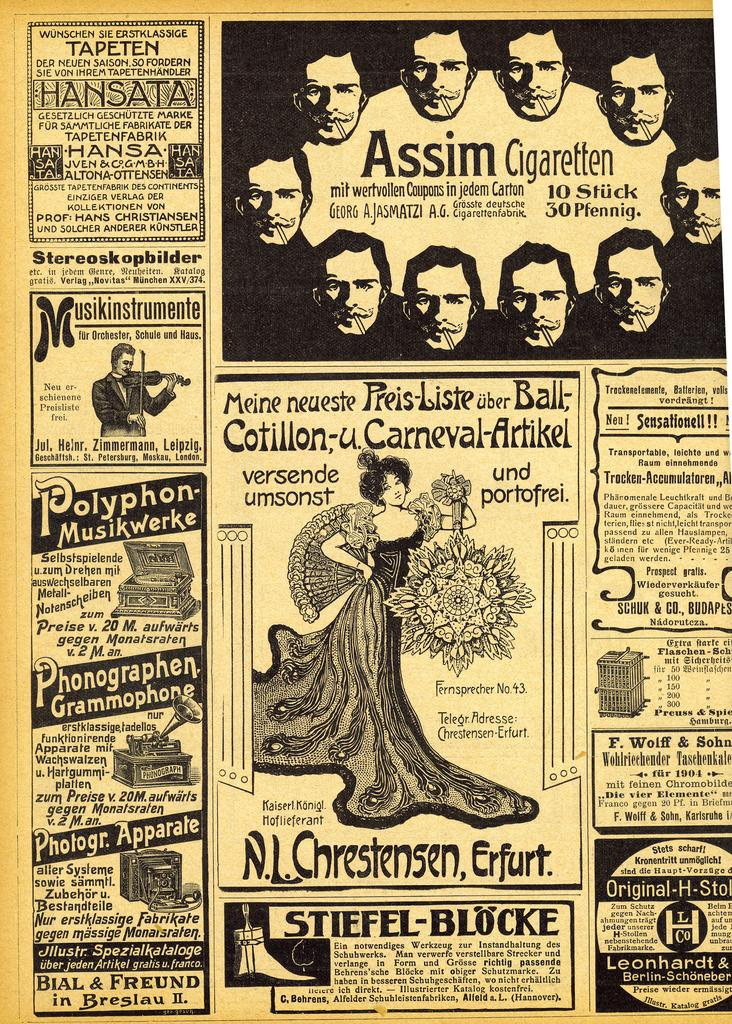<image>
Render a clear and concise summary of the photo. A poster which has the words Assim Cigaretten on it. 